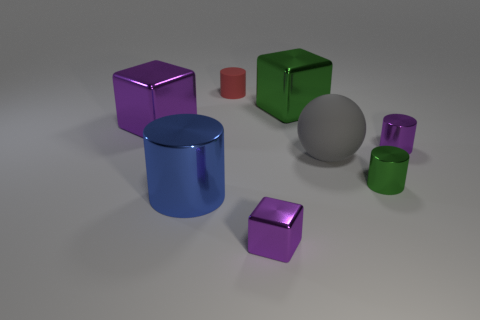There is a matte object that is the same size as the green block; what color is it?
Provide a succinct answer. Gray. There is a purple shiny cube in front of the purple metal thing to the left of the red matte cylinder; are there any gray things to the right of it?
Give a very brief answer. Yes. What size is the gray rubber thing?
Ensure brevity in your answer.  Large. How many things are large shiny things or small green shiny cylinders?
Keep it short and to the point. 4. The other small block that is made of the same material as the green block is what color?
Your answer should be compact. Purple. There is a small metallic thing that is behind the green metal cylinder; is it the same shape as the small matte object?
Your answer should be very brief. Yes. How many things are either metal cylinders left of the big gray thing or shiny blocks to the right of the tiny purple block?
Your answer should be compact. 2. There is a large metallic object that is the same shape as the red matte thing; what color is it?
Provide a short and direct response. Blue. Is there any other thing that has the same shape as the large gray matte thing?
Ensure brevity in your answer.  No. Do the large green thing and the rubber object in front of the small purple cylinder have the same shape?
Your answer should be compact. No. 